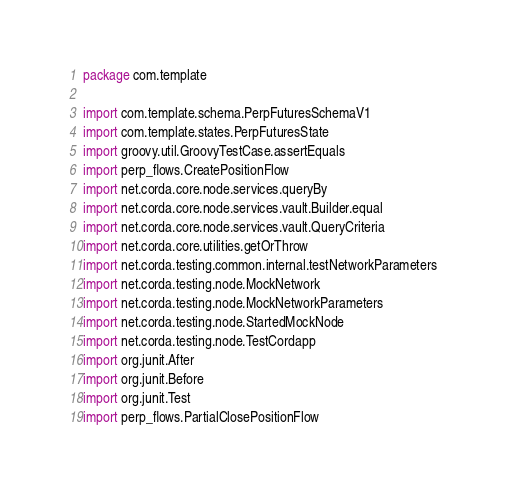Convert code to text. <code><loc_0><loc_0><loc_500><loc_500><_Kotlin_>package com.template

import com.template.schema.PerpFuturesSchemaV1
import com.template.states.PerpFuturesState
import groovy.util.GroovyTestCase.assertEquals
import perp_flows.CreatePositionFlow
import net.corda.core.node.services.queryBy
import net.corda.core.node.services.vault.Builder.equal
import net.corda.core.node.services.vault.QueryCriteria
import net.corda.core.utilities.getOrThrow
import net.corda.testing.common.internal.testNetworkParameters
import net.corda.testing.node.MockNetwork
import net.corda.testing.node.MockNetworkParameters
import net.corda.testing.node.StartedMockNode
import net.corda.testing.node.TestCordapp
import org.junit.After
import org.junit.Before
import org.junit.Test
import perp_flows.PartialClosePositionFlow</code> 